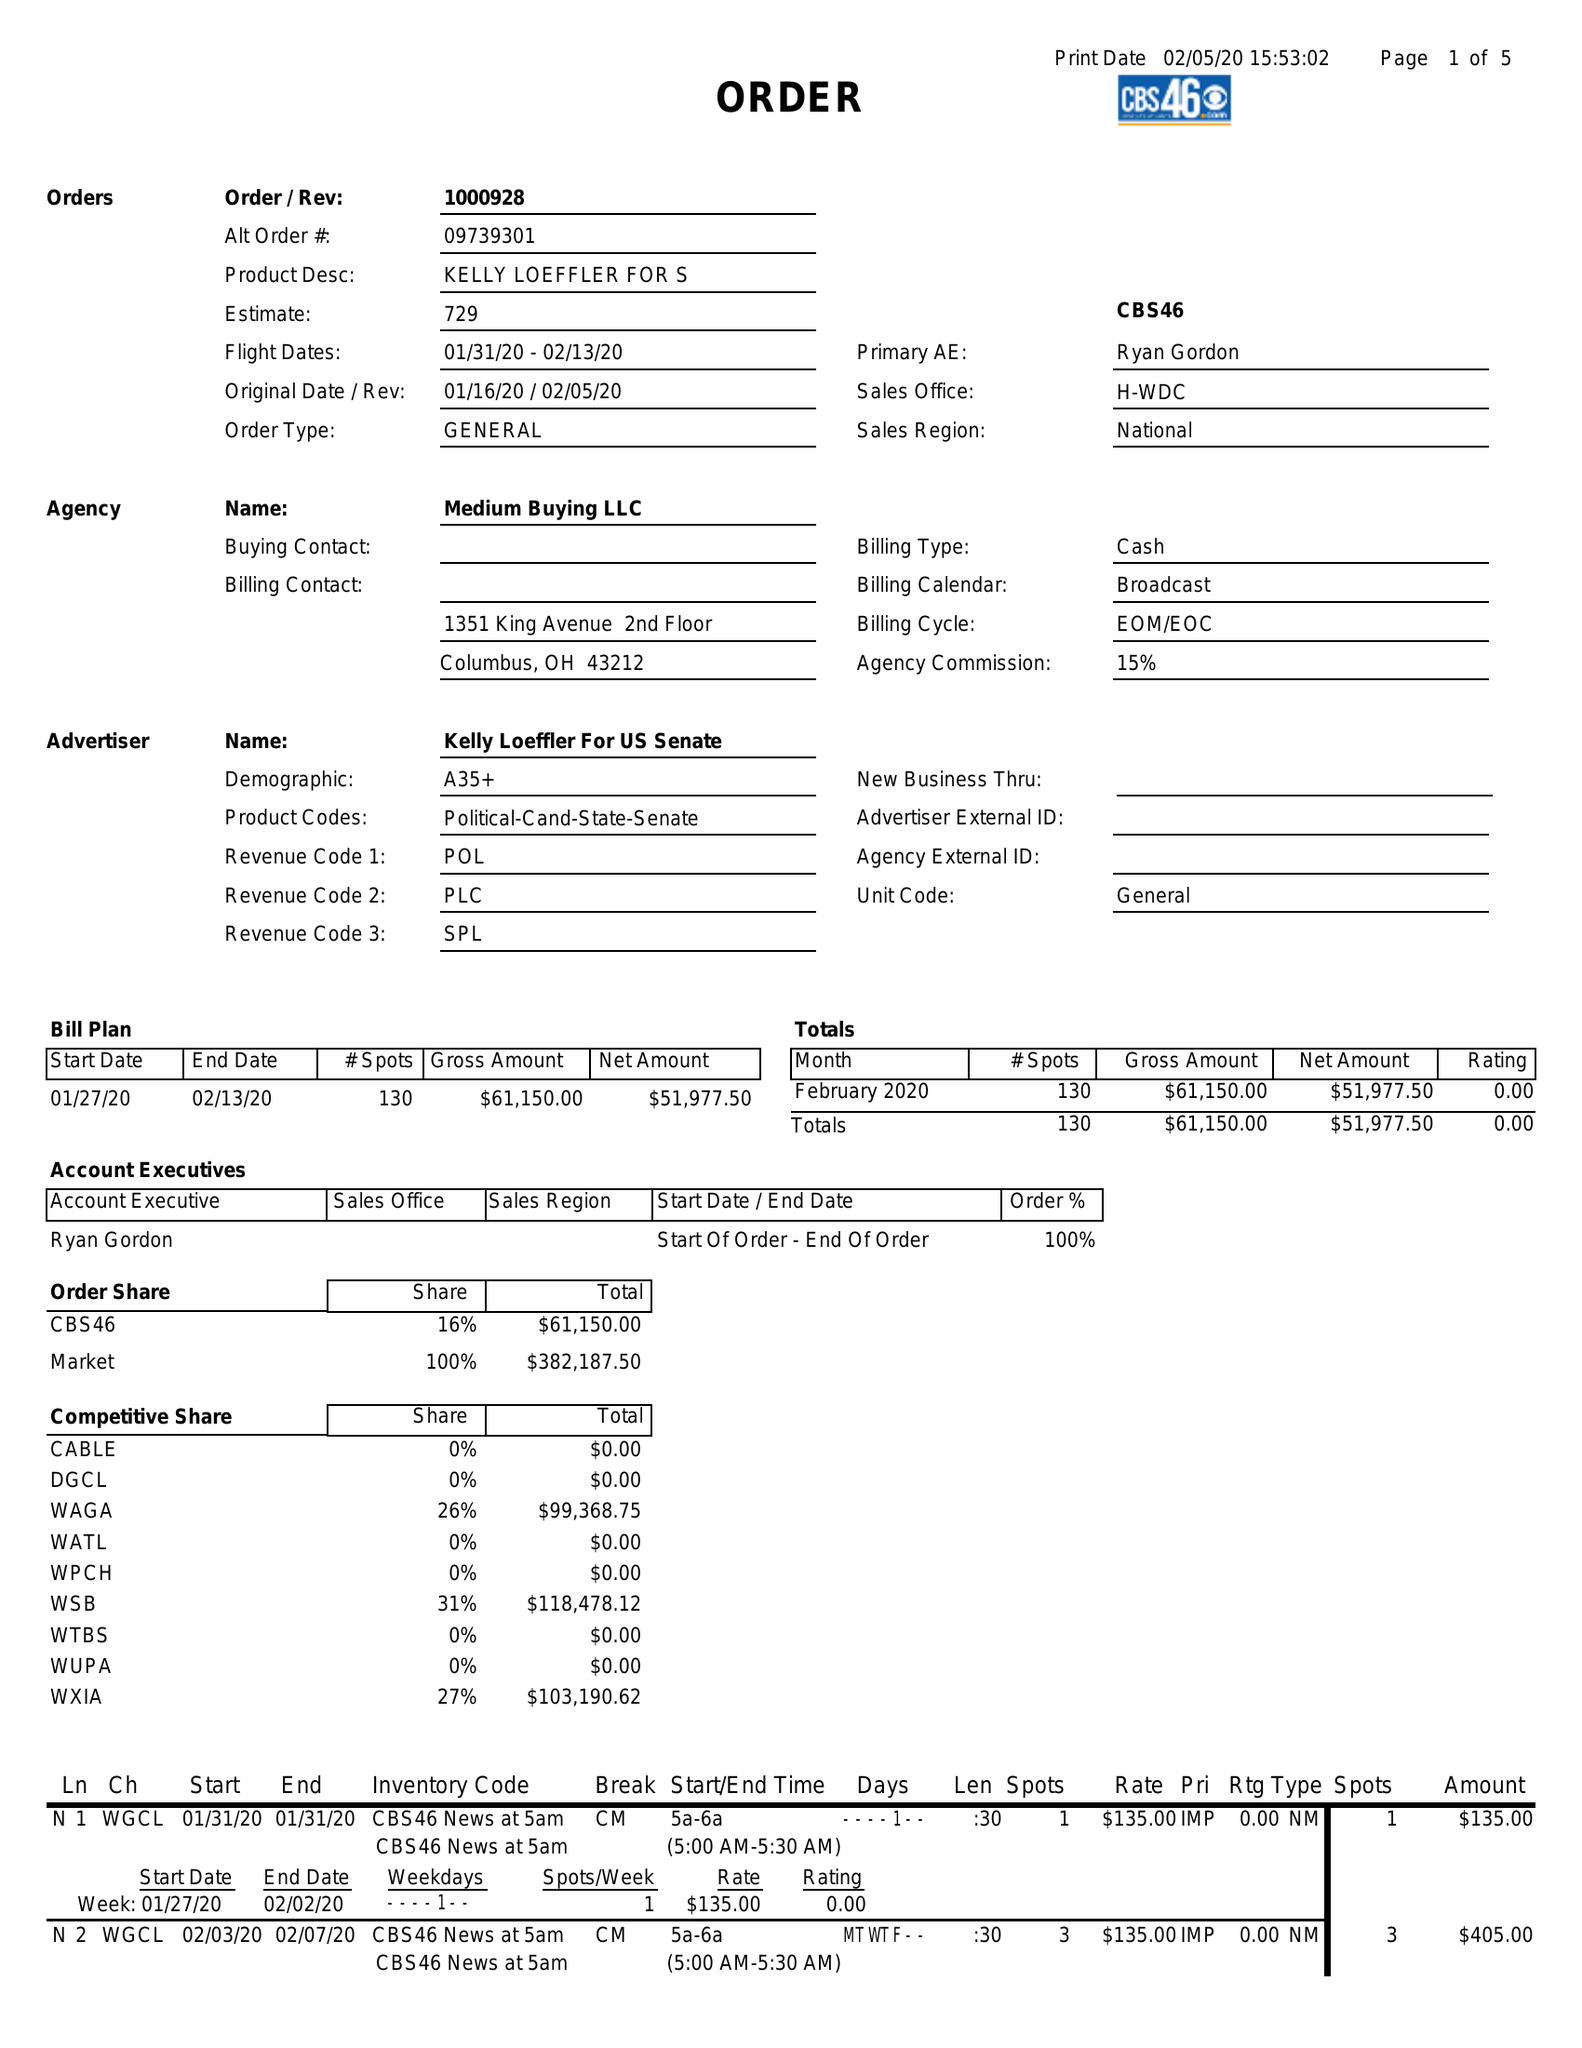What is the value for the advertiser?
Answer the question using a single word or phrase. KELLY LOEFFLER FOR US SENATE 